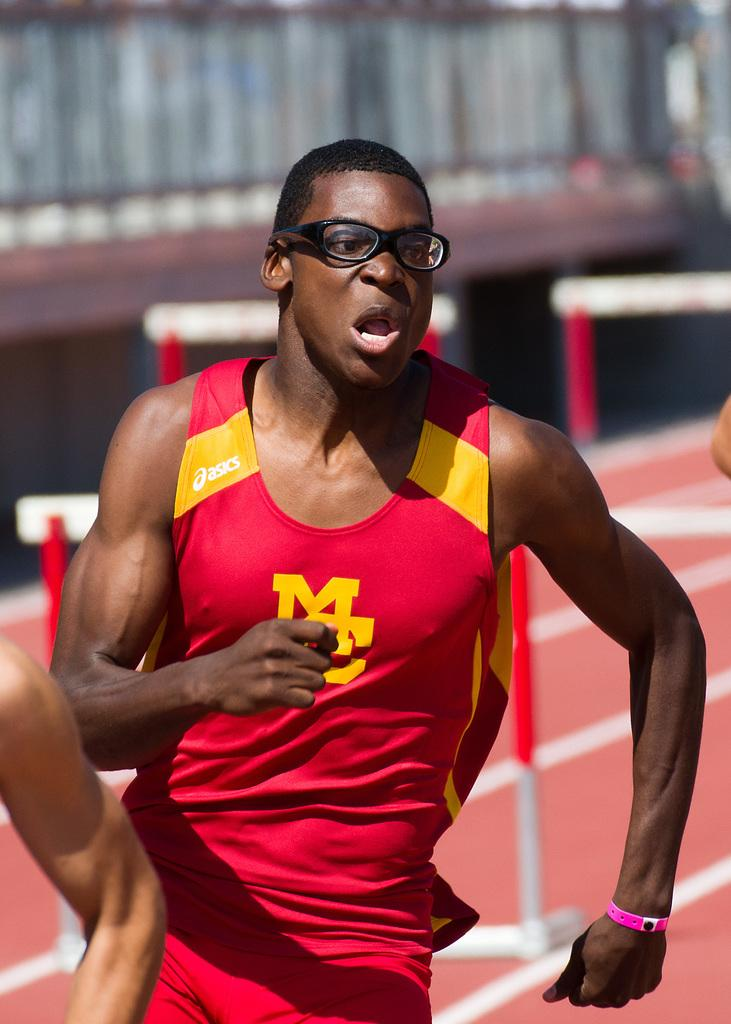<image>
Provide a brief description of the given image. An Athlete competing in a red and yellow asics shirt. 